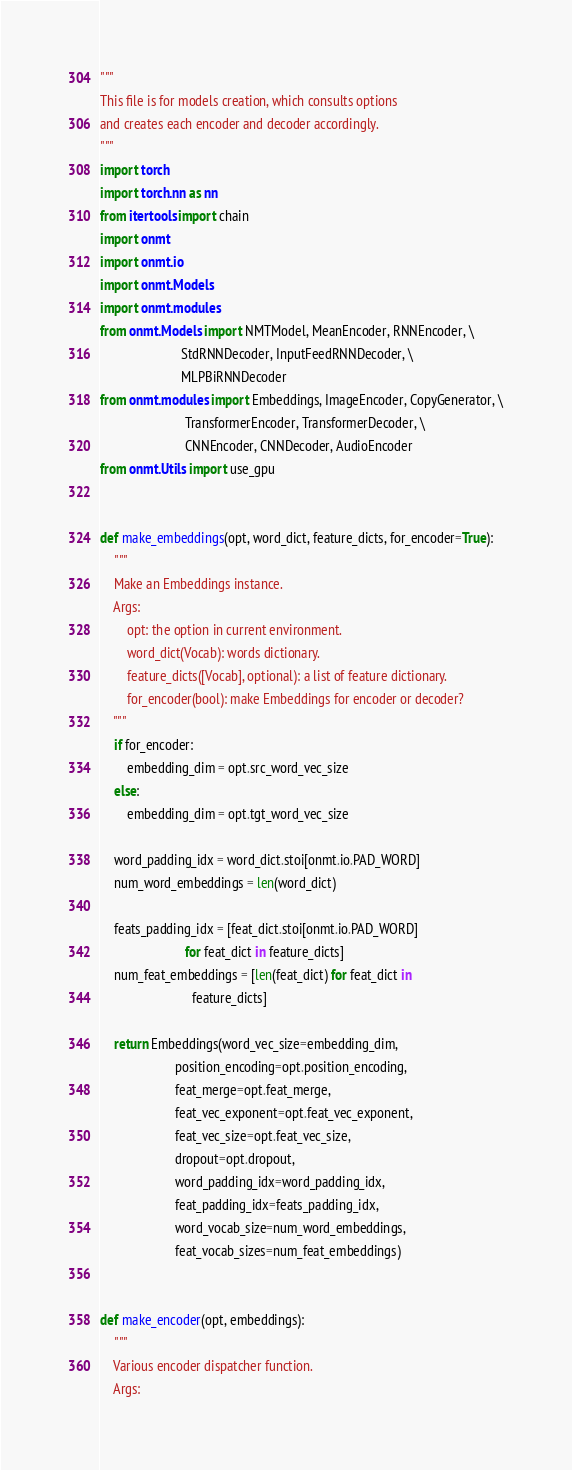Convert code to text. <code><loc_0><loc_0><loc_500><loc_500><_Python_>"""
This file is for models creation, which consults options
and creates each encoder and decoder accordingly.
"""
import torch
import torch.nn as nn
from itertools import chain
import onmt
import onmt.io
import onmt.Models
import onmt.modules
from onmt.Models import NMTModel, MeanEncoder, RNNEncoder, \
                        StdRNNDecoder, InputFeedRNNDecoder, \
                        MLPBiRNNDecoder
from onmt.modules import Embeddings, ImageEncoder, CopyGenerator, \
                         TransformerEncoder, TransformerDecoder, \
                         CNNEncoder, CNNDecoder, AudioEncoder
from onmt.Utils import use_gpu


def make_embeddings(opt, word_dict, feature_dicts, for_encoder=True):
    """
    Make an Embeddings instance.
    Args:
        opt: the option in current environment.
        word_dict(Vocab): words dictionary.
        feature_dicts([Vocab], optional): a list of feature dictionary.
        for_encoder(bool): make Embeddings for encoder or decoder?
    """
    if for_encoder:
        embedding_dim = opt.src_word_vec_size
    else:
        embedding_dim = opt.tgt_word_vec_size

    word_padding_idx = word_dict.stoi[onmt.io.PAD_WORD]
    num_word_embeddings = len(word_dict)

    feats_padding_idx = [feat_dict.stoi[onmt.io.PAD_WORD]
                         for feat_dict in feature_dicts]
    num_feat_embeddings = [len(feat_dict) for feat_dict in
                           feature_dicts]

    return Embeddings(word_vec_size=embedding_dim,
                      position_encoding=opt.position_encoding,
                      feat_merge=opt.feat_merge,
                      feat_vec_exponent=opt.feat_vec_exponent,
                      feat_vec_size=opt.feat_vec_size,
                      dropout=opt.dropout,
                      word_padding_idx=word_padding_idx,
                      feat_padding_idx=feats_padding_idx,
                      word_vocab_size=num_word_embeddings,
                      feat_vocab_sizes=num_feat_embeddings)


def make_encoder(opt, embeddings):
    """
    Various encoder dispatcher function.
    Args:</code> 